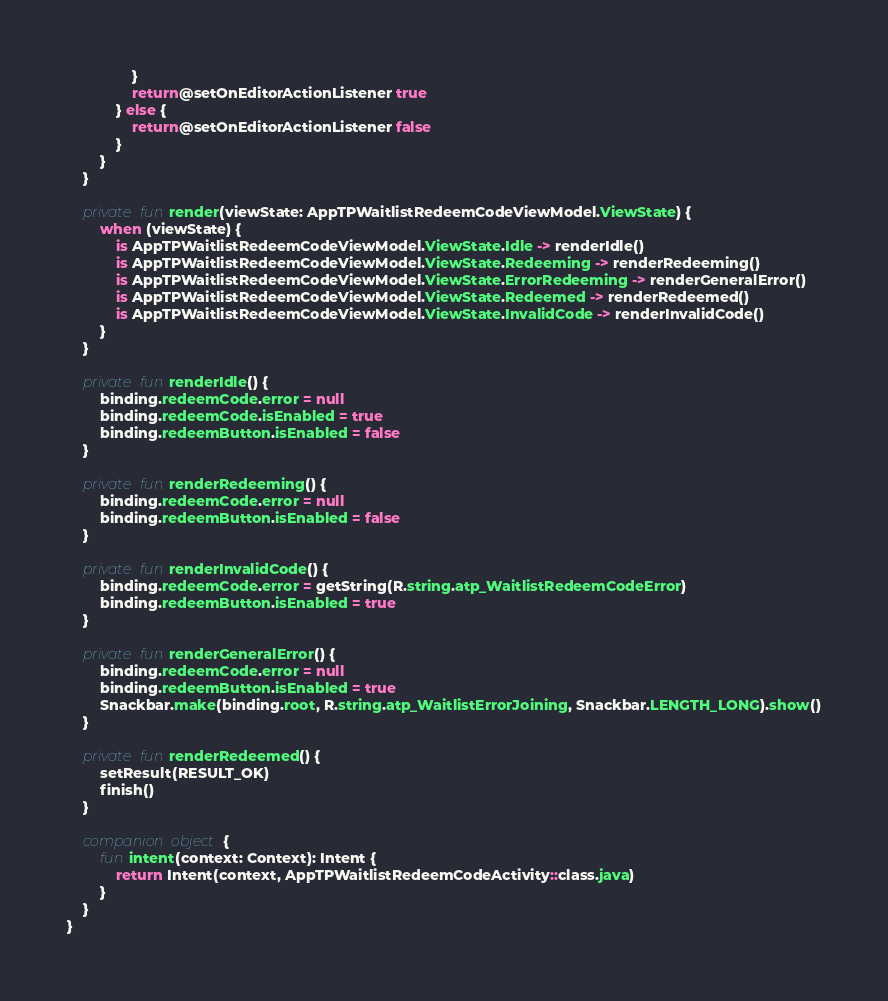Convert code to text. <code><loc_0><loc_0><loc_500><loc_500><_Kotlin_>                }
                return@setOnEditorActionListener true
            } else {
                return@setOnEditorActionListener false
            }
        }
    }

    private fun render(viewState: AppTPWaitlistRedeemCodeViewModel.ViewState) {
        when (viewState) {
            is AppTPWaitlistRedeemCodeViewModel.ViewState.Idle -> renderIdle()
            is AppTPWaitlistRedeemCodeViewModel.ViewState.Redeeming -> renderRedeeming()
            is AppTPWaitlistRedeemCodeViewModel.ViewState.ErrorRedeeming -> renderGeneralError()
            is AppTPWaitlistRedeemCodeViewModel.ViewState.Redeemed -> renderRedeemed()
            is AppTPWaitlistRedeemCodeViewModel.ViewState.InvalidCode -> renderInvalidCode()
        }
    }

    private fun renderIdle() {
        binding.redeemCode.error = null
        binding.redeemCode.isEnabled = true
        binding.redeemButton.isEnabled = false
    }

    private fun renderRedeeming() {
        binding.redeemCode.error = null
        binding.redeemButton.isEnabled = false
    }

    private fun renderInvalidCode() {
        binding.redeemCode.error = getString(R.string.atp_WaitlistRedeemCodeError)
        binding.redeemButton.isEnabled = true
    }

    private fun renderGeneralError() {
        binding.redeemCode.error = null
        binding.redeemButton.isEnabled = true
        Snackbar.make(binding.root, R.string.atp_WaitlistErrorJoining, Snackbar.LENGTH_LONG).show()
    }

    private fun renderRedeemed() {
        setResult(RESULT_OK)
        finish()
    }

    companion object {
        fun intent(context: Context): Intent {
            return Intent(context, AppTPWaitlistRedeemCodeActivity::class.java)
        }
    }
}
</code> 